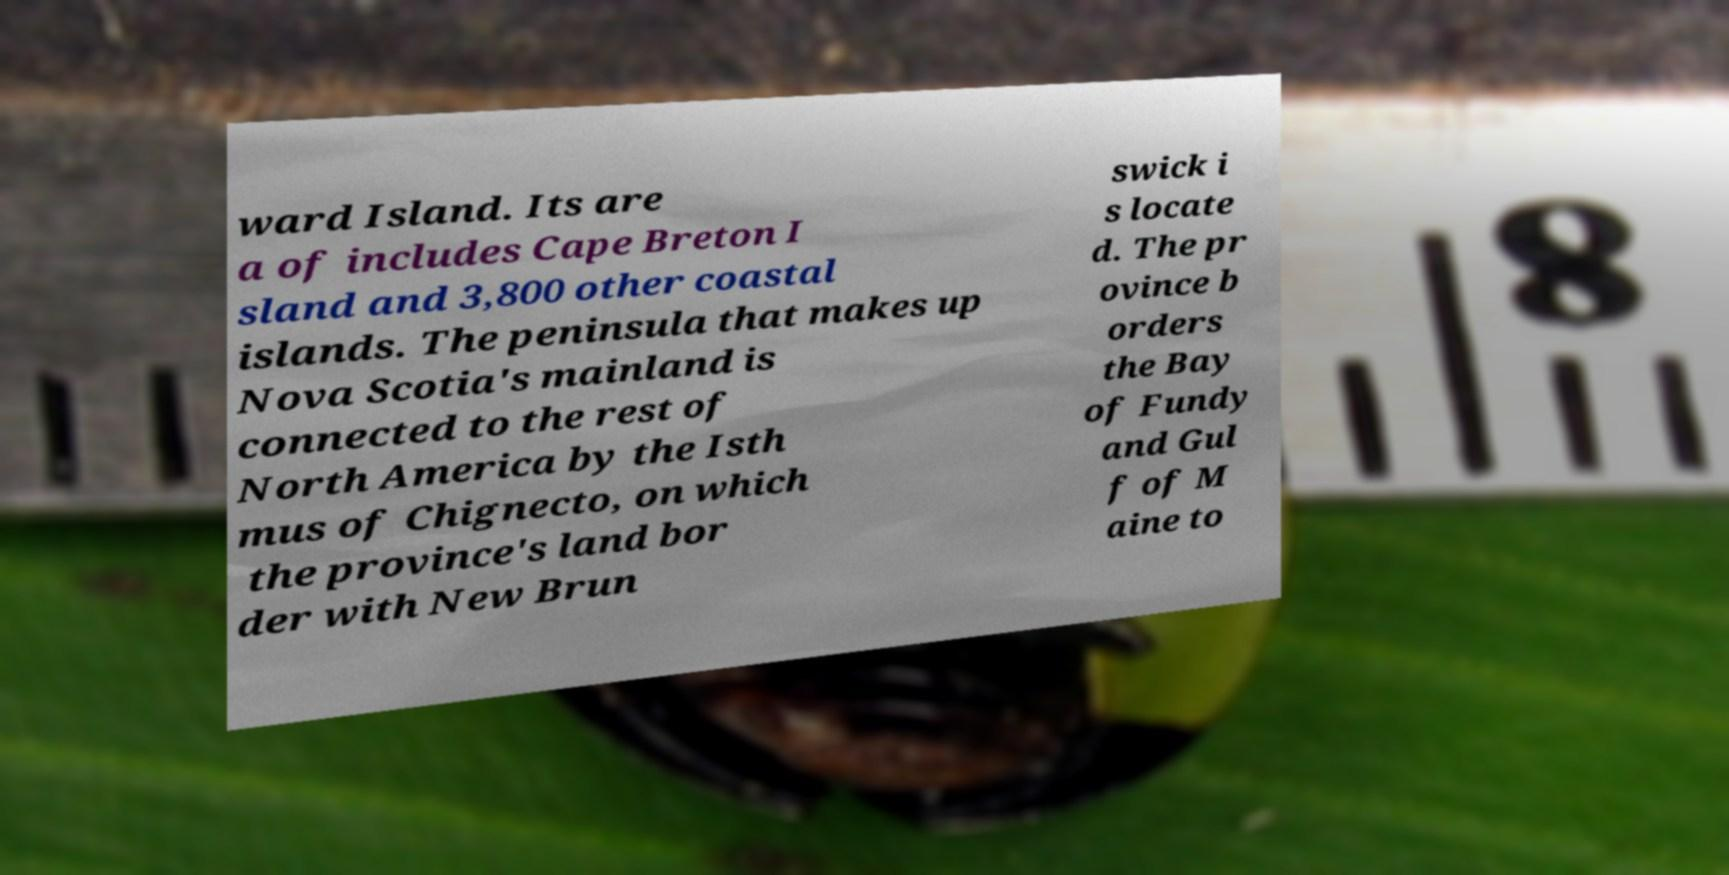There's text embedded in this image that I need extracted. Can you transcribe it verbatim? ward Island. Its are a of includes Cape Breton I sland and 3,800 other coastal islands. The peninsula that makes up Nova Scotia's mainland is connected to the rest of North America by the Isth mus of Chignecto, on which the province's land bor der with New Brun swick i s locate d. The pr ovince b orders the Bay of Fundy and Gul f of M aine to 